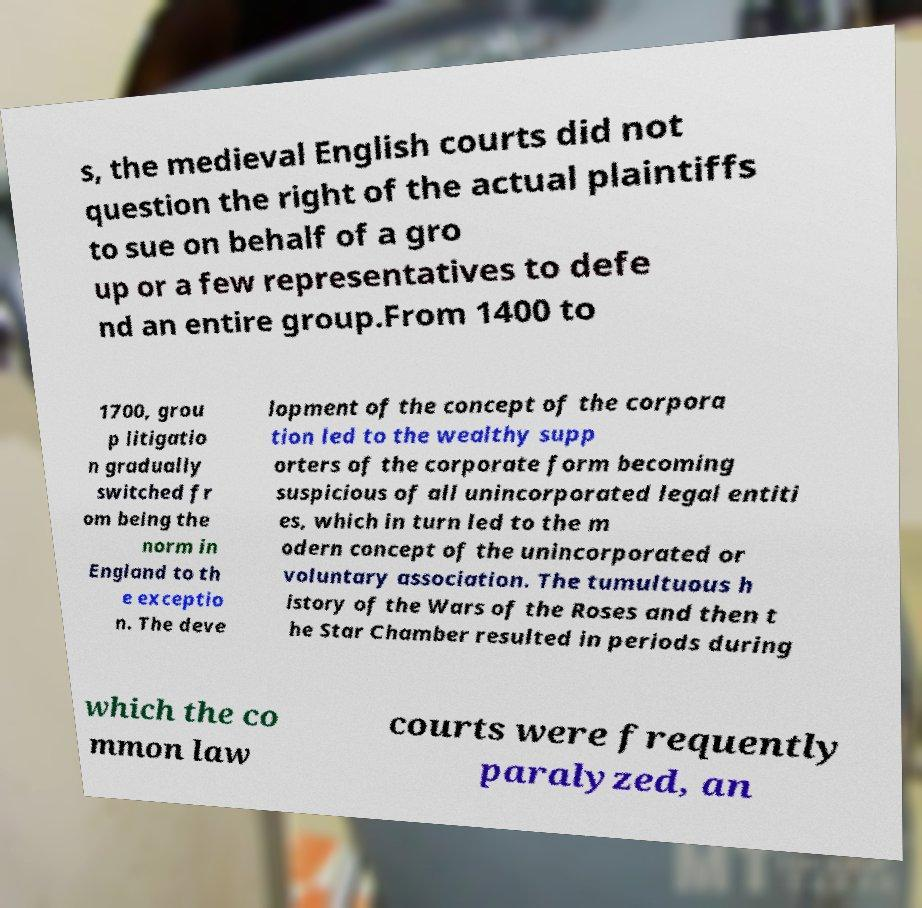Can you read and provide the text displayed in the image?This photo seems to have some interesting text. Can you extract and type it out for me? s, the medieval English courts did not question the right of the actual plaintiffs to sue on behalf of a gro up or a few representatives to defe nd an entire group.From 1400 to 1700, grou p litigatio n gradually switched fr om being the norm in England to th e exceptio n. The deve lopment of the concept of the corpora tion led to the wealthy supp orters of the corporate form becoming suspicious of all unincorporated legal entiti es, which in turn led to the m odern concept of the unincorporated or voluntary association. The tumultuous h istory of the Wars of the Roses and then t he Star Chamber resulted in periods during which the co mmon law courts were frequently paralyzed, an 